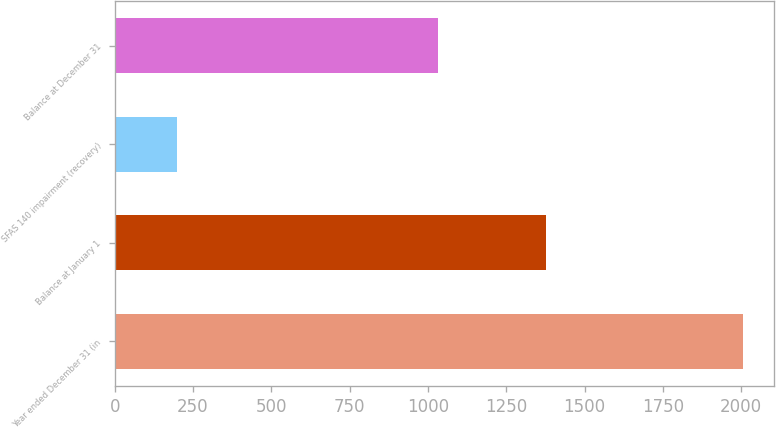Convert chart to OTSL. <chart><loc_0><loc_0><loc_500><loc_500><bar_chart><fcel>Year ended December 31 (in<fcel>Balance at January 1<fcel>SFAS 140 impairment (recovery)<fcel>Balance at December 31<nl><fcel>2004<fcel>1378<fcel>198<fcel>1031<nl></chart> 